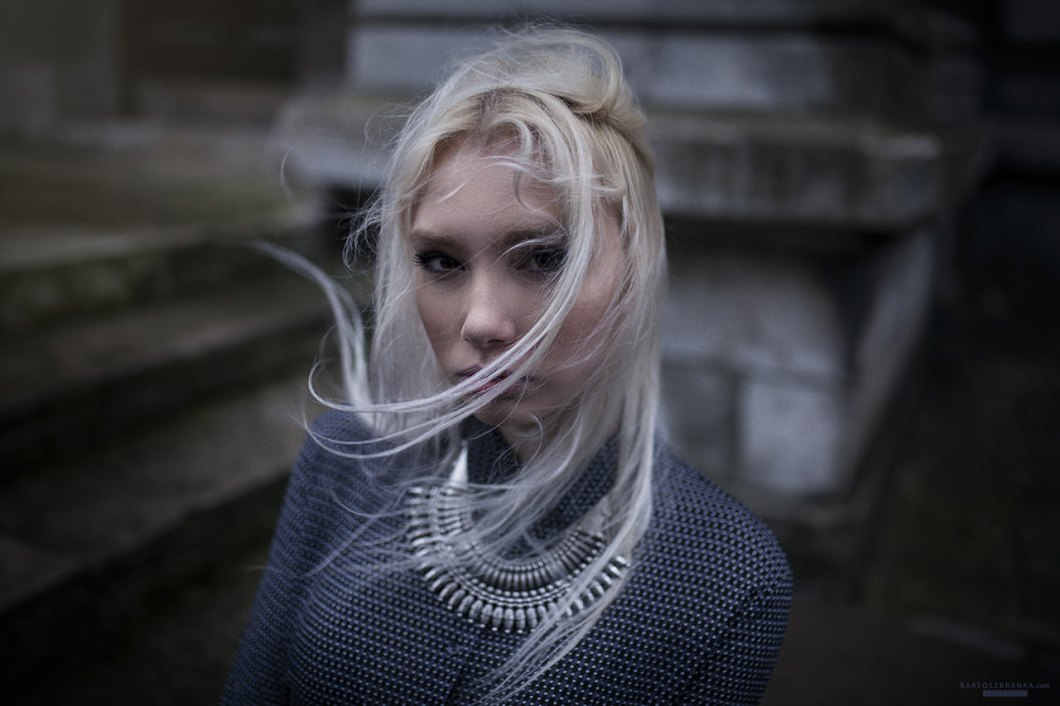Imagine this is a scene from a fantasy world where the woman's sweater has magical properties. What are these properties and how do they shape her destiny? In a mystical realm where every piece of clothing harbors a story untold, her sweater is woven from the enchanted wool of the elusive Moon Sheep. This ancient wool, imbued with lunar magic, possesses the ability to shield its wearer from harm and grant them insight into the hearts of those around them. As she dons this garment, she feels an aura of peace and clarity wash over her. Her journey takes her through dark forests and forgotten ruins, yet she remains unharmed and keenly aware of the intentions of those she encounters. The sweater's magic becomes her silent guardian and wise advisor, guiding her towards a destiny where she is destined to unite the warring kingdoms through her wisdom and newfound understanding of others' emotions. What kind of attire do you think complements her sweater perfectly, making the outfit both historically grounded and aesthetically timeless? To complement her chunky, dark grey sweater, a full-length, flowing skirt made of a soft, contrasting fabric such as silk or velvet in a deep, jewel-toned color would be ideal. The fluidity of the skirt would juxtapose nicely with the texture of the knit, creating a balance between rigidity and gracefulness. Completing the ensemble with a pair of lace-up leather boots would ground the outfit in a historical context, evoking a sense of timeless elegance. Adding delicate, vintage-inspired jewelry, perhaps featuring intricate metalwork or gemstones, would enhance the overall aesthetic, providing a cohesive look that blurs the lines between periods and styles.  The woman is writing a letter to someone important. What do you think she is writing about, and how does the atmosphere of the scene influence her words? In the solitude of the moody, overcast day, she finds herself penning a letter filled with heartfelt words and unsaid emotions. The melancholic atmosphere greatly influences her tone, infusing her writing with an air of wistfulness and gravity. She might be writing to an estranged loved one, perhaps addressing unresolved feelings and shared memories marked by the sharegpt4v/same kind of grey skies that now hang above her. Her words flow with a raw honesty, reflective of the quiet surroundings and the introspective ambiance. She writes about her hopes for reconciliation, the persistent ache of separation, and her dreams of a future where their paths might once again converge. The weathered steps and ancient stone architecture around her act as silent witnesses to her vulnerability, her ink-stained fingers conveying each sentiment with deliberate, tender strokes. 